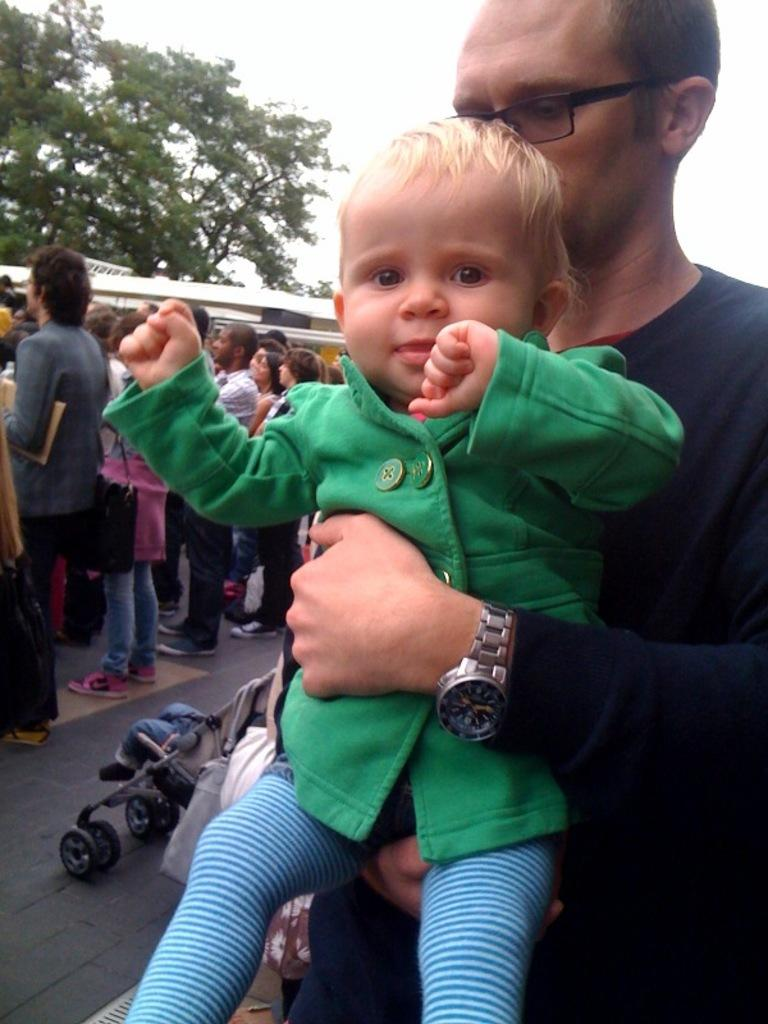What is the man in the image doing? The man is holding a baby in the image. Are there any other people present in the image? Yes, there are people standing beside the man and baby. What can be seen in the background of the image? There is a tree and the sky visible in the background of the image. How many kittens are playing with the baby in the image? There are no kittens present in the image; it only features a man holding a baby and other people standing nearby. 